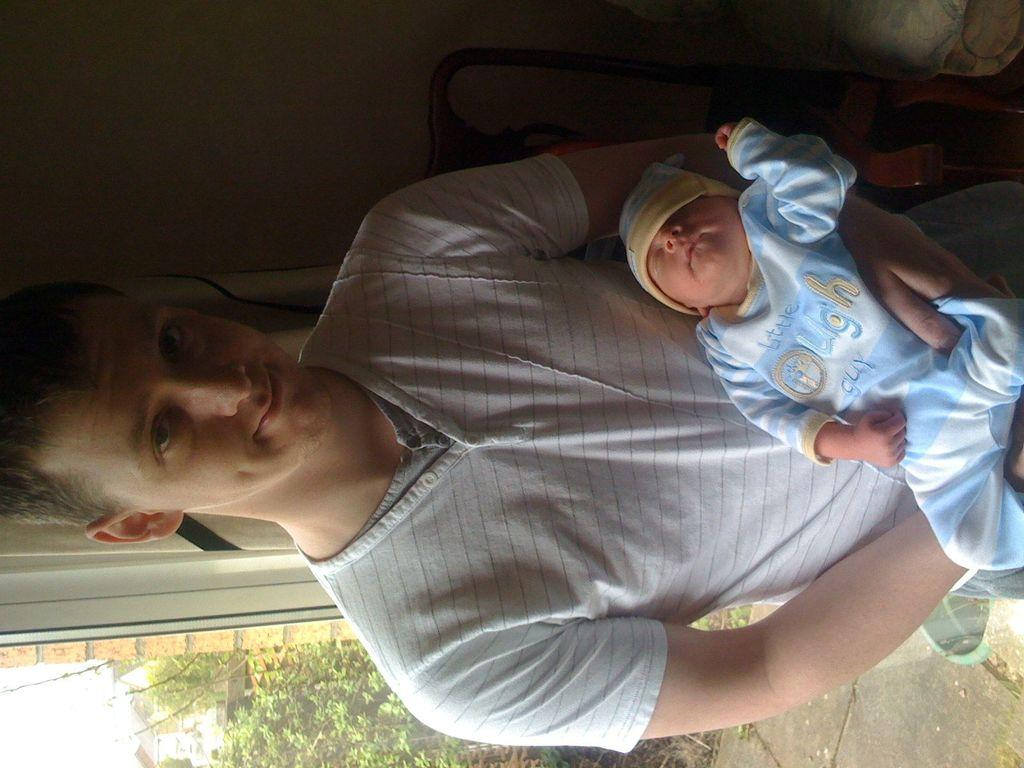Who is present in the image? There is a man in the image. What is the man doing in the image? The man is holding a baby. What is the man's facial expression in the image? The man is smiling. What can be seen in the background of the image? There is a wall in the background of the image. What type of vegetation is visible at the bottom of the image? There are plants visible at the bottom of the image. What type of pen is the man using to mark his territory in the image? There is no pen or indication of marking territory present in the image. 